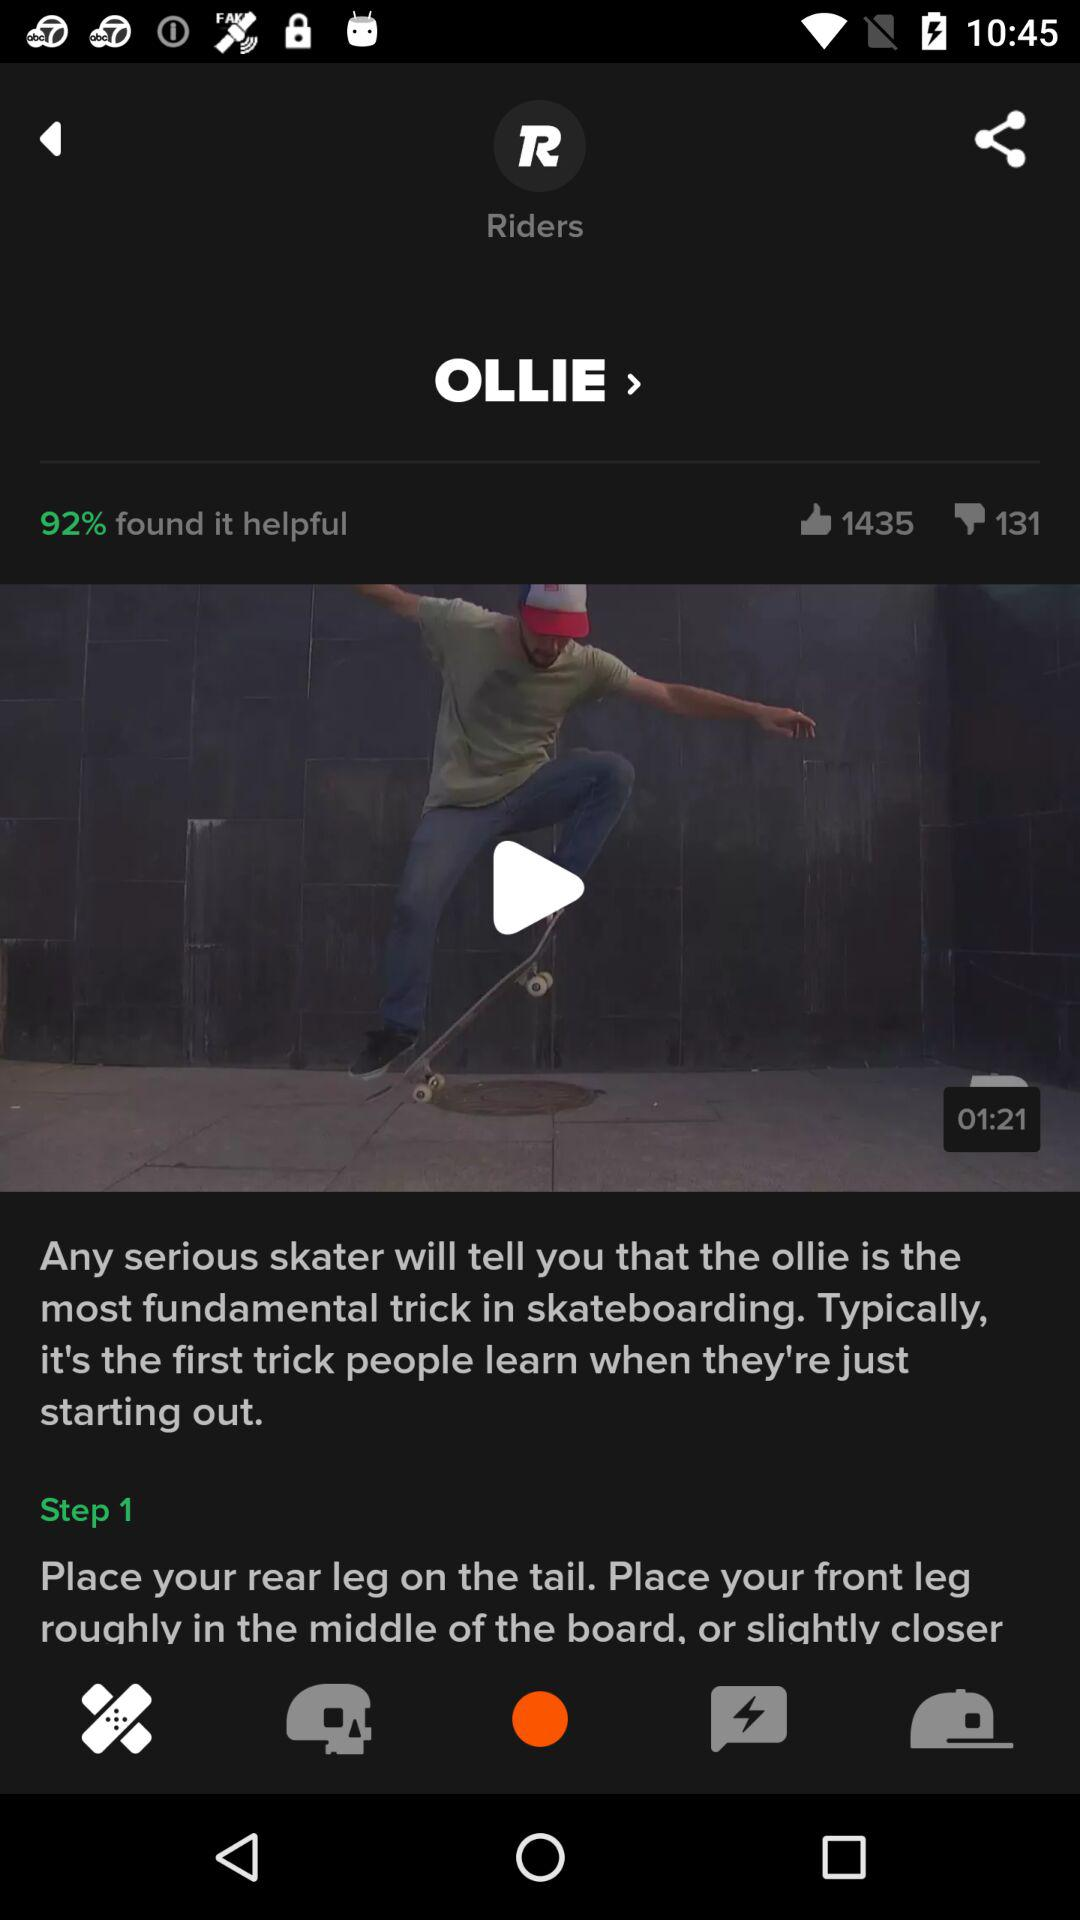What is the number of dislikes? The number of dislikes is 131. 